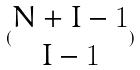<formula> <loc_0><loc_0><loc_500><loc_500>( \begin{matrix} N + I - 1 \\ I - 1 \end{matrix} )</formula> 